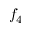Convert formula to latex. <formula><loc_0><loc_0><loc_500><loc_500>f _ { 4 }</formula> 